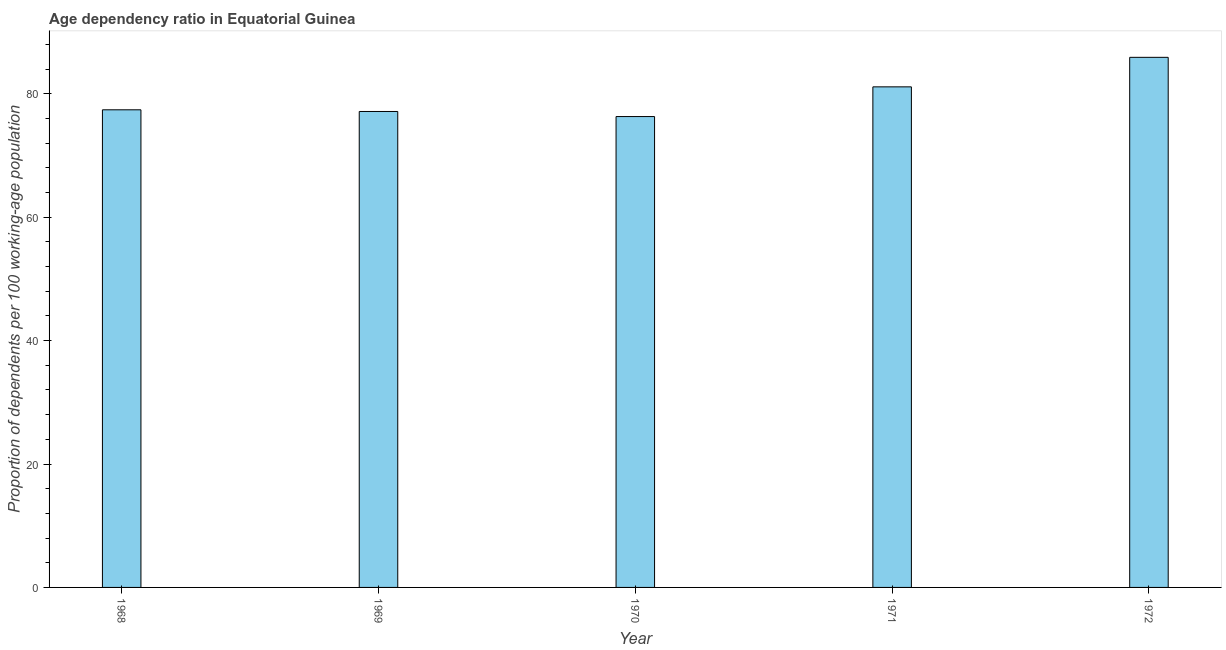What is the title of the graph?
Make the answer very short. Age dependency ratio in Equatorial Guinea. What is the label or title of the Y-axis?
Make the answer very short. Proportion of dependents per 100 working-age population. What is the age dependency ratio in 1968?
Offer a terse response. 77.41. Across all years, what is the maximum age dependency ratio?
Offer a very short reply. 85.91. Across all years, what is the minimum age dependency ratio?
Offer a terse response. 76.31. In which year was the age dependency ratio maximum?
Make the answer very short. 1972. In which year was the age dependency ratio minimum?
Make the answer very short. 1970. What is the sum of the age dependency ratio?
Provide a succinct answer. 397.89. What is the difference between the age dependency ratio in 1971 and 1972?
Your answer should be compact. -4.78. What is the average age dependency ratio per year?
Keep it short and to the point. 79.58. What is the median age dependency ratio?
Offer a terse response. 77.41. Do a majority of the years between 1972 and 1970 (inclusive) have age dependency ratio greater than 64 ?
Your answer should be compact. Yes. What is the ratio of the age dependency ratio in 1970 to that in 1972?
Your response must be concise. 0.89. What is the difference between the highest and the second highest age dependency ratio?
Provide a short and direct response. 4.78. Is the sum of the age dependency ratio in 1968 and 1971 greater than the maximum age dependency ratio across all years?
Provide a succinct answer. Yes. In how many years, is the age dependency ratio greater than the average age dependency ratio taken over all years?
Your answer should be very brief. 2. What is the difference between two consecutive major ticks on the Y-axis?
Your answer should be very brief. 20. What is the Proportion of dependents per 100 working-age population of 1968?
Your answer should be very brief. 77.41. What is the Proportion of dependents per 100 working-age population in 1969?
Keep it short and to the point. 77.13. What is the Proportion of dependents per 100 working-age population in 1970?
Offer a terse response. 76.31. What is the Proportion of dependents per 100 working-age population of 1971?
Provide a succinct answer. 81.13. What is the Proportion of dependents per 100 working-age population in 1972?
Ensure brevity in your answer.  85.91. What is the difference between the Proportion of dependents per 100 working-age population in 1968 and 1969?
Your answer should be very brief. 0.27. What is the difference between the Proportion of dependents per 100 working-age population in 1968 and 1970?
Provide a short and direct response. 1.1. What is the difference between the Proportion of dependents per 100 working-age population in 1968 and 1971?
Make the answer very short. -3.72. What is the difference between the Proportion of dependents per 100 working-age population in 1968 and 1972?
Give a very brief answer. -8.5. What is the difference between the Proportion of dependents per 100 working-age population in 1969 and 1970?
Offer a terse response. 0.82. What is the difference between the Proportion of dependents per 100 working-age population in 1969 and 1971?
Your response must be concise. -3.99. What is the difference between the Proportion of dependents per 100 working-age population in 1969 and 1972?
Make the answer very short. -8.78. What is the difference between the Proportion of dependents per 100 working-age population in 1970 and 1971?
Give a very brief answer. -4.82. What is the difference between the Proportion of dependents per 100 working-age population in 1970 and 1972?
Your response must be concise. -9.6. What is the difference between the Proportion of dependents per 100 working-age population in 1971 and 1972?
Your answer should be very brief. -4.78. What is the ratio of the Proportion of dependents per 100 working-age population in 1968 to that in 1970?
Your response must be concise. 1.01. What is the ratio of the Proportion of dependents per 100 working-age population in 1968 to that in 1971?
Your response must be concise. 0.95. What is the ratio of the Proportion of dependents per 100 working-age population in 1968 to that in 1972?
Make the answer very short. 0.9. What is the ratio of the Proportion of dependents per 100 working-age population in 1969 to that in 1971?
Give a very brief answer. 0.95. What is the ratio of the Proportion of dependents per 100 working-age population in 1969 to that in 1972?
Offer a terse response. 0.9. What is the ratio of the Proportion of dependents per 100 working-age population in 1970 to that in 1971?
Offer a very short reply. 0.94. What is the ratio of the Proportion of dependents per 100 working-age population in 1970 to that in 1972?
Your answer should be very brief. 0.89. What is the ratio of the Proportion of dependents per 100 working-age population in 1971 to that in 1972?
Make the answer very short. 0.94. 